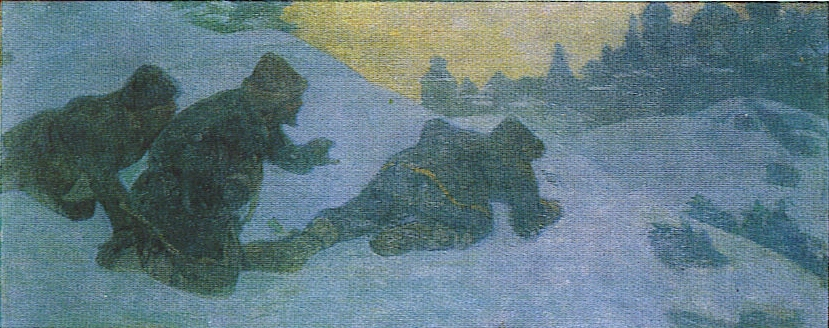Describe the mood and atmosphere of the scene. The mood of the scene is quite somber and perhaps a bit foreboding. The cool blues and greens create a sense of cold and hardship, while the warm yellow light offers a glimmer of hope or a destination. The overall atmosphere is one of resilience and determination, as the figures face the harsh conditions head-on. Could you describe a typical day for the people in this image? In a rural, historical Russian setting during winter, a typical day for these individuals would likely start early in the morning. They might be preparing for a day of hard labor, such as hunting, gathering firewood, or traveling to nearby villages for trade. The cold would require them to wear heavy clothing, and they would have to navigate the snow-covered landscape, often facing harsh weather conditions. Meals would consist of hearty, warm foods to sustain them throughout the day, and evenings would be spent around a fire, sharing stories and preparing for the next day. 